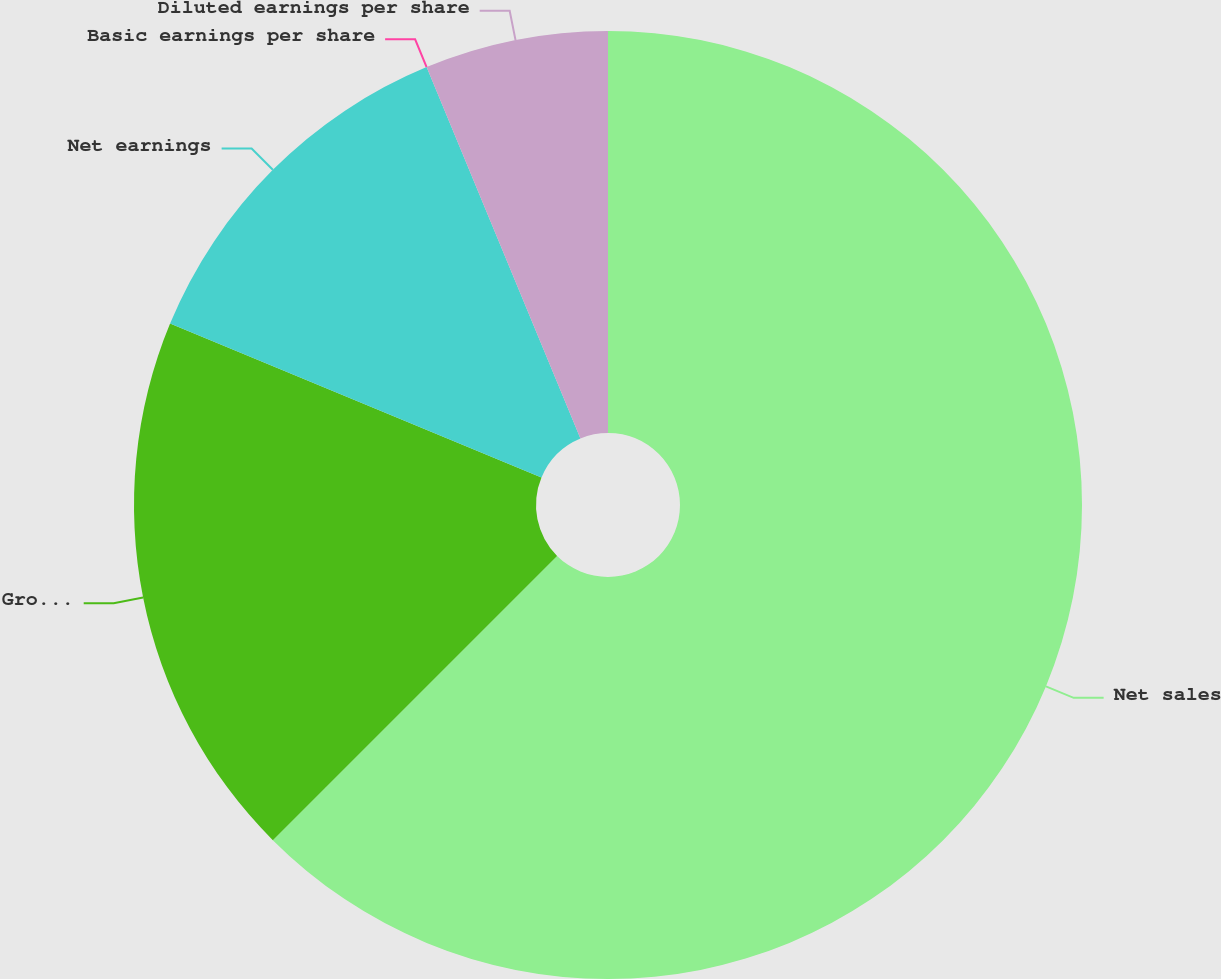Convert chart. <chart><loc_0><loc_0><loc_500><loc_500><pie_chart><fcel>Net sales<fcel>Gross profit<fcel>Net earnings<fcel>Basic earnings per share<fcel>Diluted earnings per share<nl><fcel>62.5%<fcel>18.75%<fcel>12.5%<fcel>0.0%<fcel>6.25%<nl></chart> 